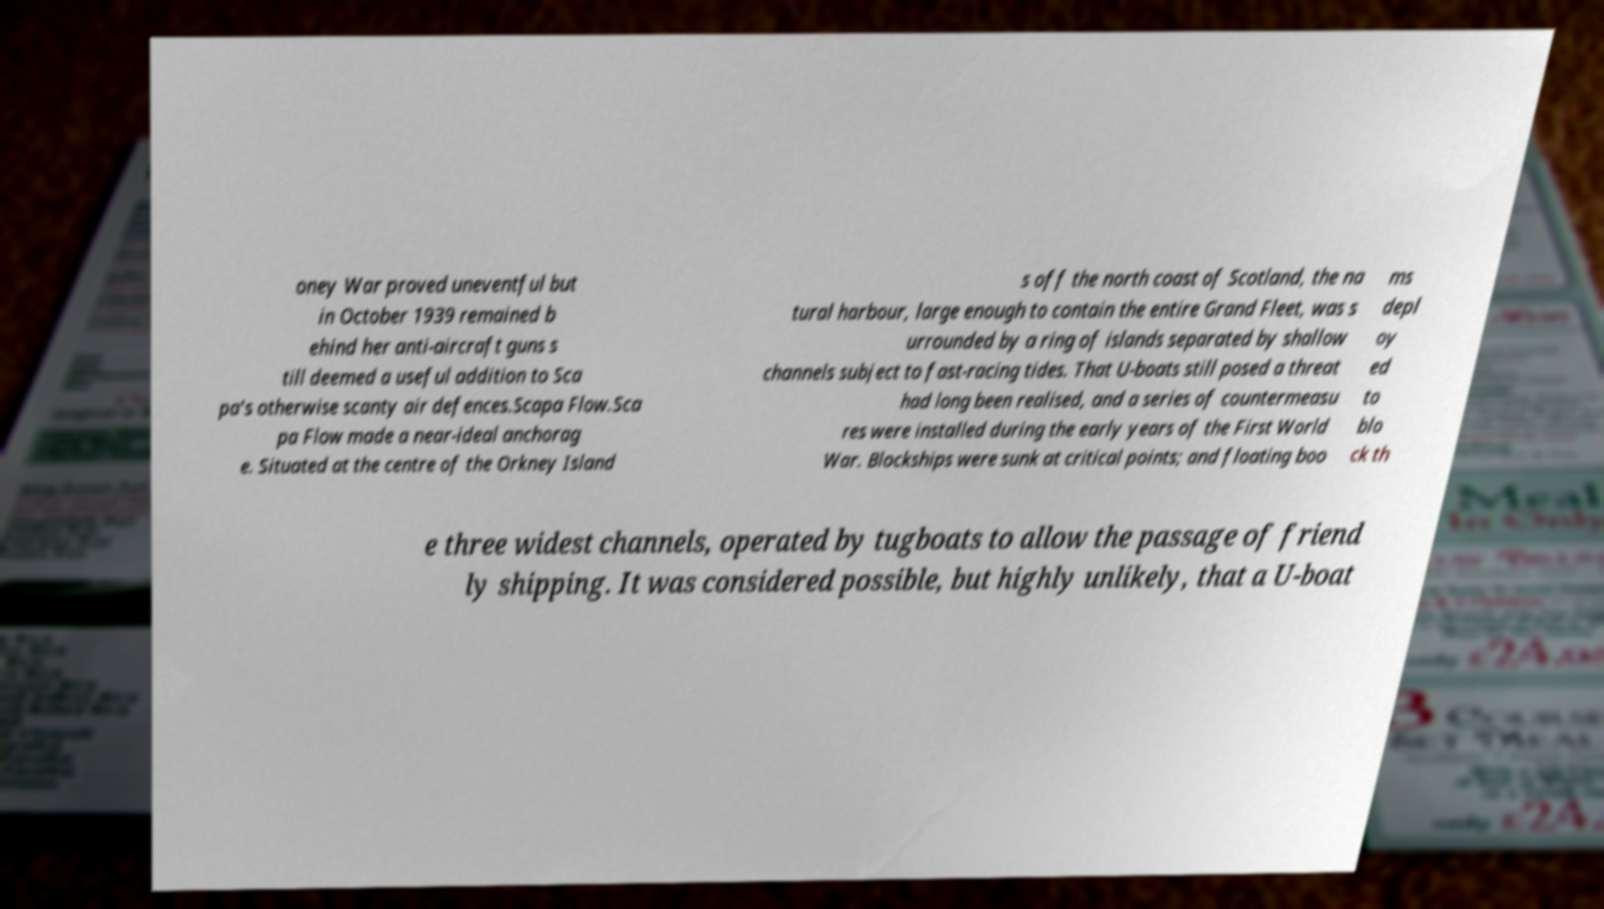I need the written content from this picture converted into text. Can you do that? oney War proved uneventful but in October 1939 remained b ehind her anti-aircraft guns s till deemed a useful addition to Sca pa's otherwise scanty air defences.Scapa Flow.Sca pa Flow made a near-ideal anchorag e. Situated at the centre of the Orkney Island s off the north coast of Scotland, the na tural harbour, large enough to contain the entire Grand Fleet, was s urrounded by a ring of islands separated by shallow channels subject to fast-racing tides. That U-boats still posed a threat had long been realised, and a series of countermeasu res were installed during the early years of the First World War. Blockships were sunk at critical points; and floating boo ms depl oy ed to blo ck th e three widest channels, operated by tugboats to allow the passage of friend ly shipping. It was considered possible, but highly unlikely, that a U-boat 